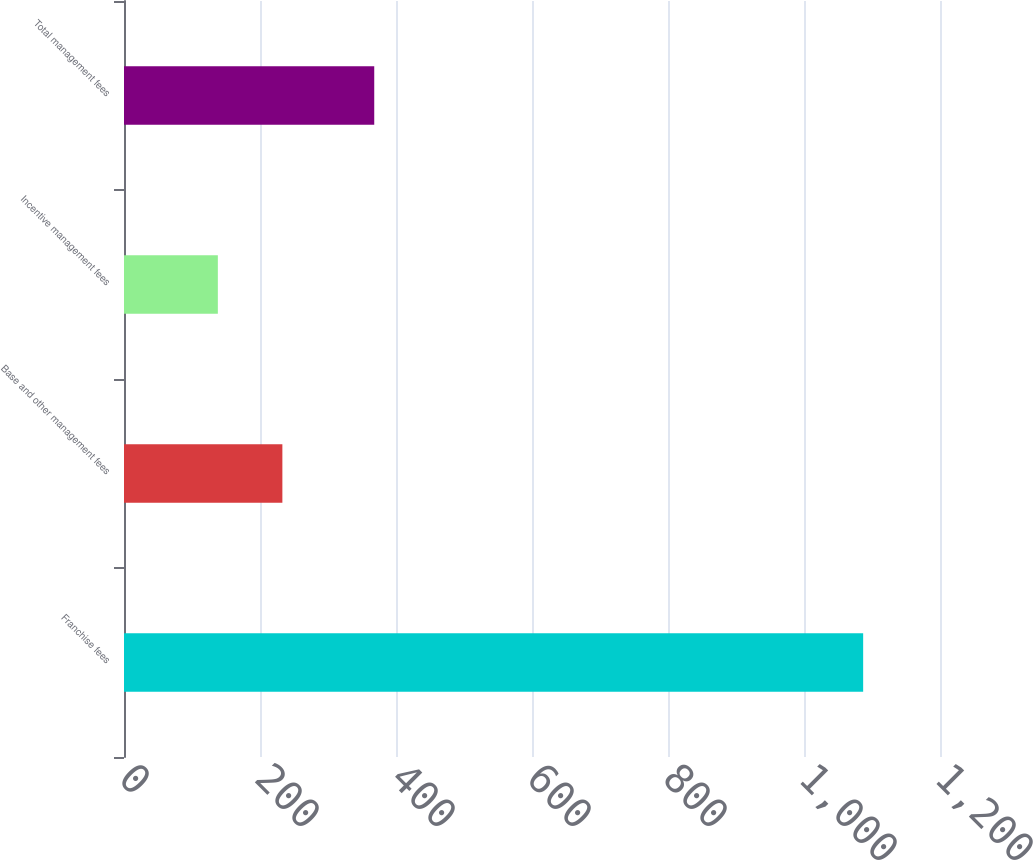Convert chart to OTSL. <chart><loc_0><loc_0><loc_500><loc_500><bar_chart><fcel>Franchise fees<fcel>Base and other management fees<fcel>Incentive management fees<fcel>Total management fees<nl><fcel>1087<fcel>232.9<fcel>138<fcel>368<nl></chart> 